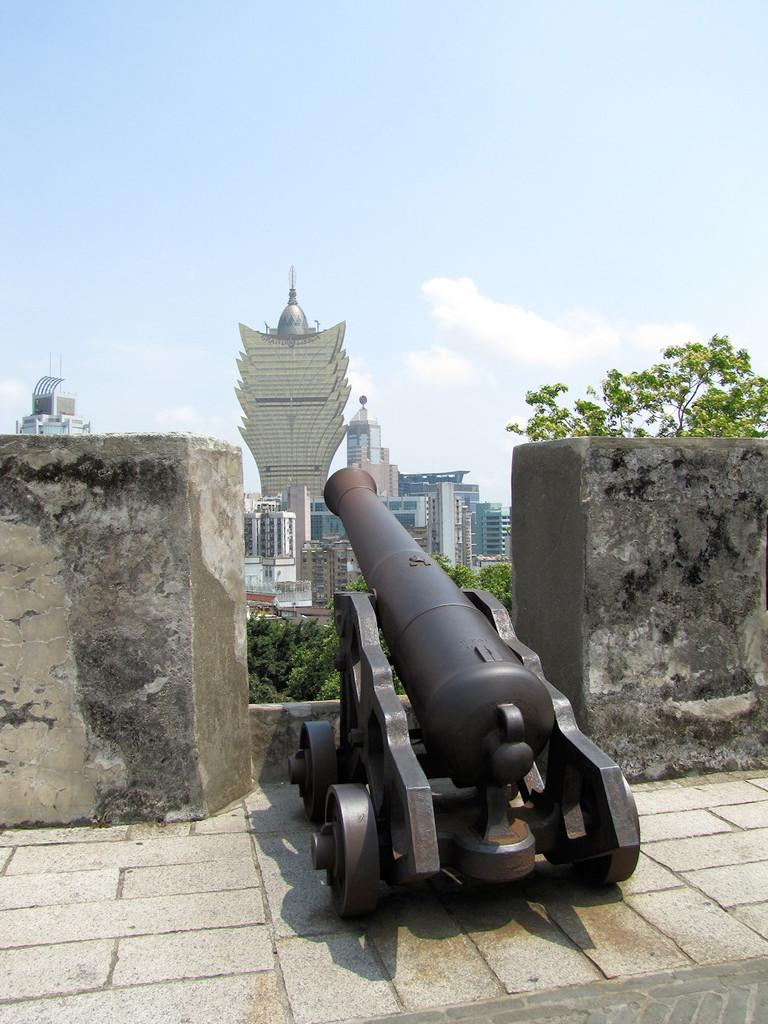What object is on the floor in the image? There is a cannon on the floor in the image. Where is the cannon located in relation to the walls? The cannon is between walls in the image. What type of natural elements can be seen in the image? Trees are visible in the image. What type of man-made structures are present in the image? There are buildings in the image. What is visible in the sky in the image? Clouds are present in the sky in the image. What type of quiver is hanging on the wall in the image? There is no quiver present in the image; it features a cannon on the floor between walls, trees, buildings, and clouds in the sky. 